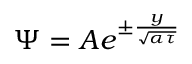<formula> <loc_0><loc_0><loc_500><loc_500>\Psi = A e ^ { \pm \frac { y } { \sqrt { \alpha \tau } } }</formula> 